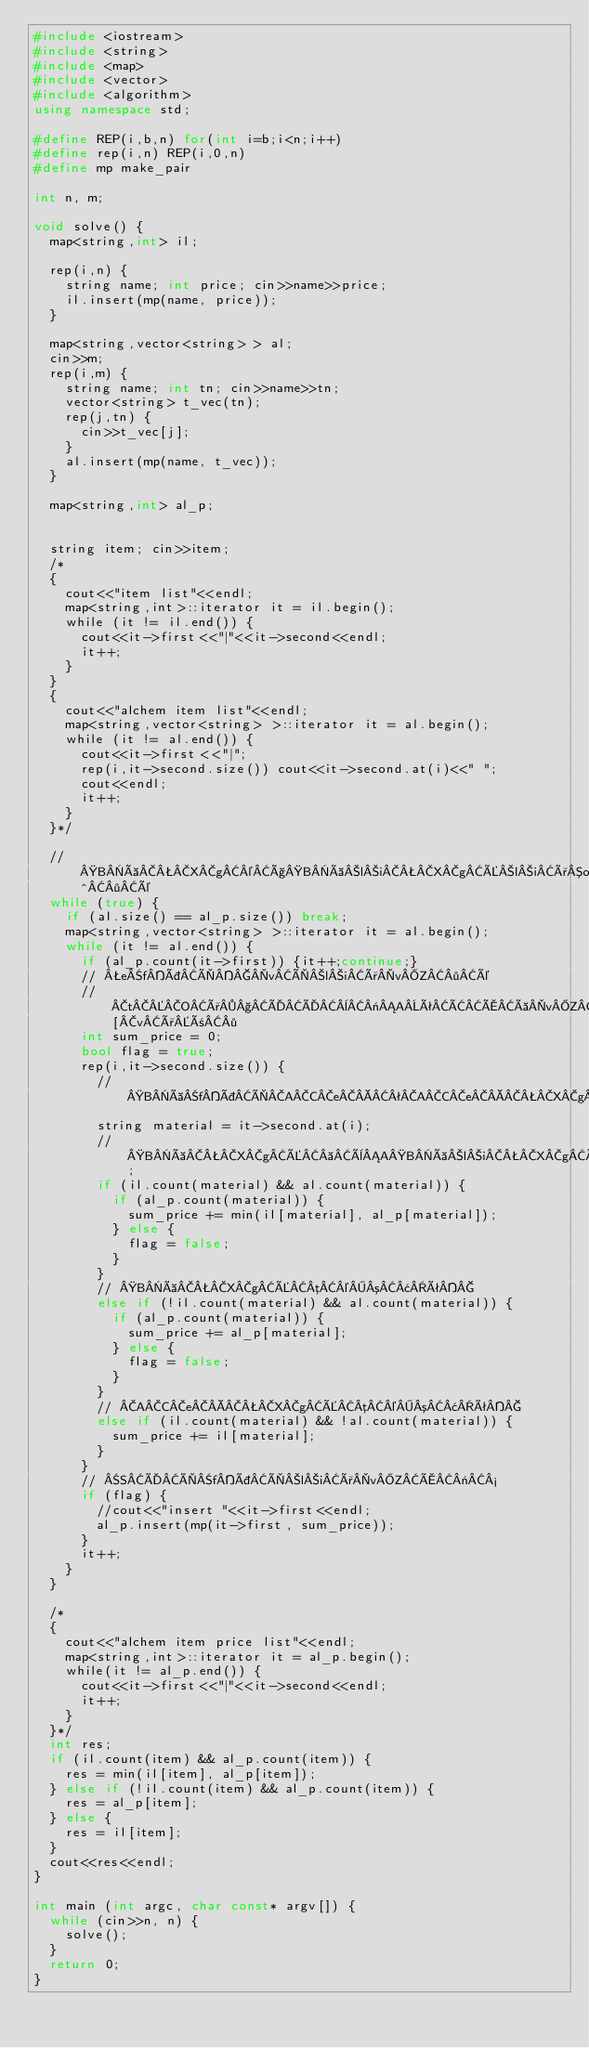<code> <loc_0><loc_0><loc_500><loc_500><_C++_>#include <iostream>
#include <string>
#include <map>
#include <vector>
#include <algorithm>
using namespace std;

#define REP(i,b,n) for(int i=b;i<n;i++)
#define rep(i,n) REP(i,0,n)
#define mp make_pair

int n, m;

void solve() {
  map<string,int> il;

  rep(i,n) {
    string name; int price; cin>>name>>price;
    il.insert(mp(name, price));
  }
  
  map<string,vector<string> > al;
  cin>>m;
  rep(i,m) {
    string name; int tn; cin>>name>>tn;
    vector<string> t_vec(tn);
    rep(j,tn) {
      cin>>t_vec[j];
    }
    al.insert(mp(name, t_vec));
  }
  
  map<string,int> al_p;
  
  
  string item; cin>>item;
  /*
  {
    cout<<"item list"<<endl;
    map<string,int>::iterator it = il.begin();
    while (it != il.end()) {
      cout<<it->first<<"|"<<it->second<<endl;
      it++;
    }
  }
  {
    cout<<"alchem item list"<<endl;
    map<string,vector<string> >::iterator it = al.begin();
    while (it != al.end()) {
      cout<<it->first<<"|";
      rep(i,it->second.size()) cout<<it->second.at(i)<<" ";
      cout<<endl;
      it++;
    }
  }*/
    
  // BàXg©çBàliXgÉliðo^·é
  while (true) {
    if (al.size() == al_p.size()) break;
    map<string,vector<string> >::iterator it = al.begin();
    while (it != al.end()) {
      if (al_p.count(it->first)) {it++;continue;}
      // efÞÌvÌliðvZ·é
      // tOð§ÄÄ¨«AêÂÅàvZÅ«È¢fÞª¶Ý·éêÍ[vðñ·
      int sum_price = 0;
      bool flag = true;
      rep(i,it->second.size()) {
        // BàfÞÌACeªACeXgAÜ½ÍBàXgÉ é©
        string material = it->second.at(i);
        // BàXgÉ èABàliXgÉ³¢êÍcontinue;
        if (il.count(material) && al.count(material)) {
          if (al_p.count(material)) {
            sum_price += min(il[material], al_p[material]);
          } else {
            flag = false;
          }
        }
        // BàXgÉµ©³¢ê
        else if (!il.count(material) && al.count(material)) {
          if (al_p.count(material)) {
            sum_price += al_p[material];
          } else {
            flag = false;
          }
        }
        // ACeXgÉµ©³¢ê
        else if (il.count(material) && !al.count(material)) {
          sum_price += il[material];
        }
      }
      // SÄÌfÞÌliðvZÅ«½
      if (flag) {
        //cout<<"insert "<<it->first<<endl;
        al_p.insert(mp(it->first, sum_price));
      }
      it++;
    }
  }
  
  /*
  {
    cout<<"alchem item price list"<<endl;
    map<string,int>::iterator it = al_p.begin();
    while(it != al_p.end()) {
      cout<<it->first<<"|"<<it->second<<endl;
      it++;
    }
  }*/
  int res;
  if (il.count(item) && al_p.count(item)) {
    res = min(il[item], al_p[item]);
  } else if (!il.count(item) && al_p.count(item)) {
    res = al_p[item];
  } else {
    res = il[item];
  }
  cout<<res<<endl;
}

int main (int argc, char const* argv[]) {
  while (cin>>n, n) {
    solve();
  }
  return 0;
}</code> 